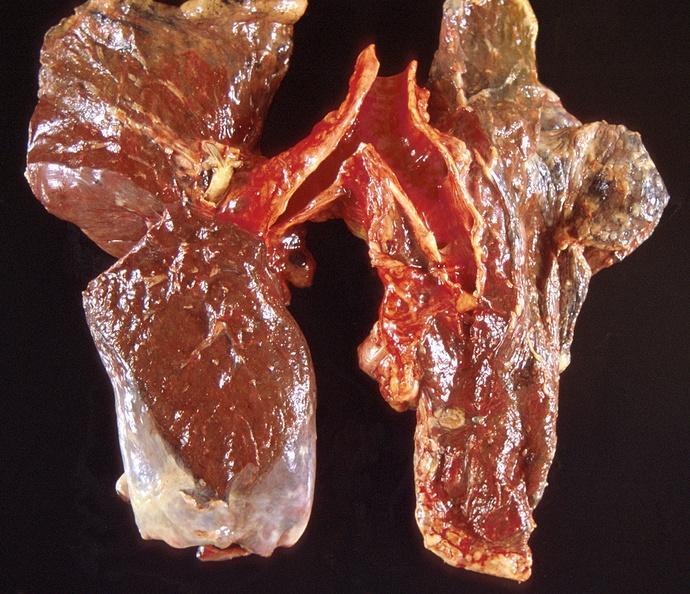where is this?
Answer the question using a single word or phrase. Lung 